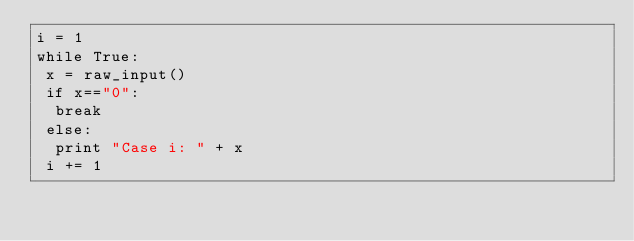Convert code to text. <code><loc_0><loc_0><loc_500><loc_500><_Python_>i = 1
while True:
 x = raw_input()
 if x=="0":
  break
 else:
  print "Case i: " + x
 i += 1</code> 